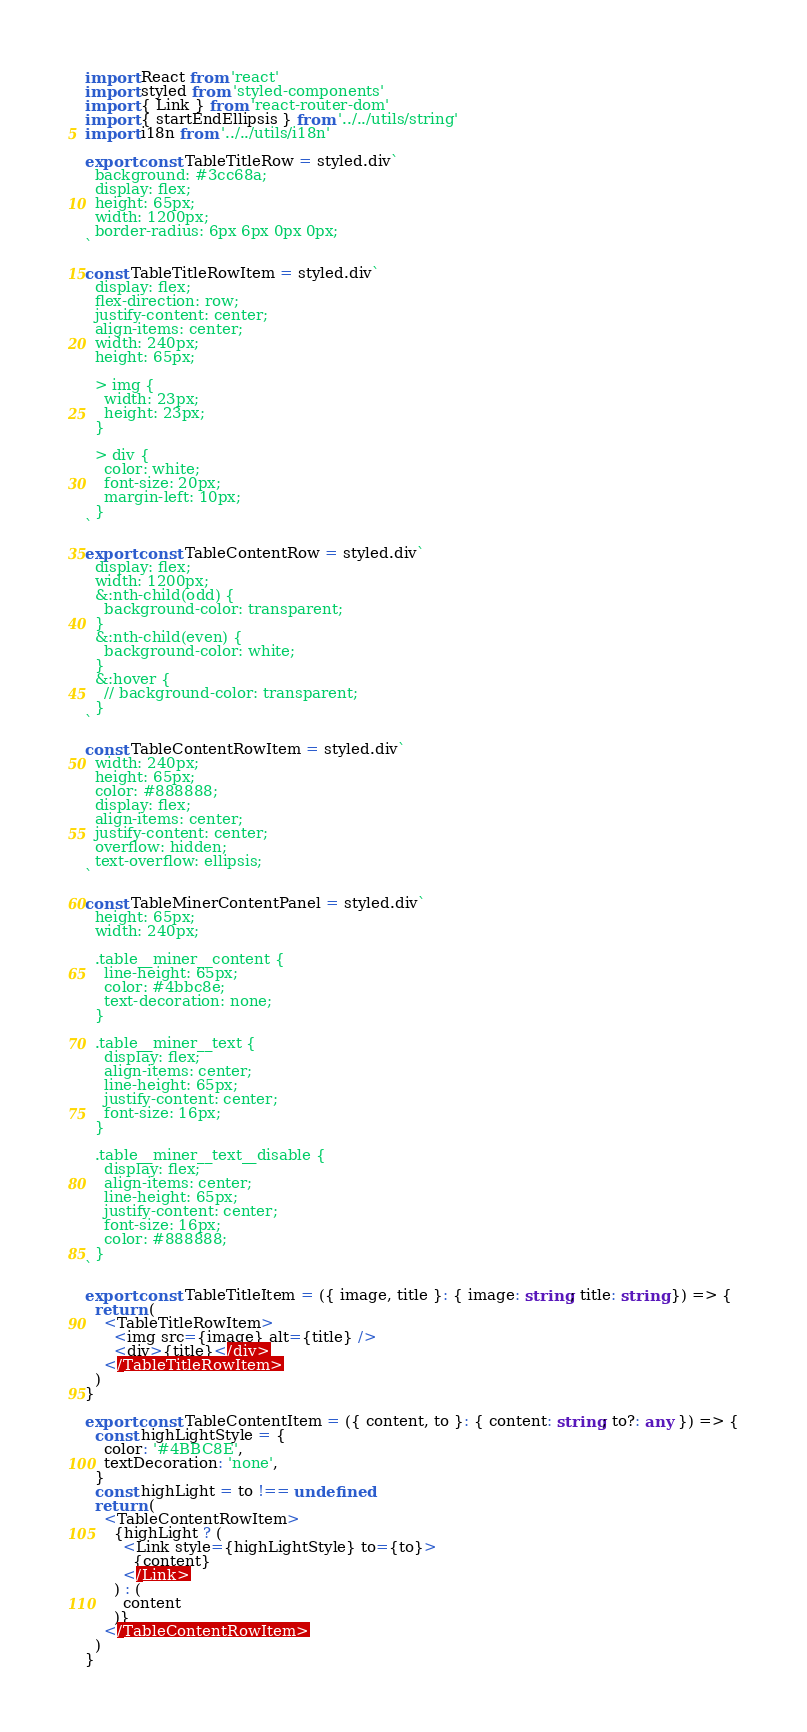<code> <loc_0><loc_0><loc_500><loc_500><_TypeScript_>import React from 'react'
import styled from 'styled-components'
import { Link } from 'react-router-dom'
import { startEndEllipsis } from '../../utils/string'
import i18n from '../../utils/i18n'

export const TableTitleRow = styled.div`
  background: #3cc68a;
  display: flex;
  height: 65px;
  width: 1200px;
  border-radius: 6px 6px 0px 0px;
`

const TableTitleRowItem = styled.div`
  display: flex;
  flex-direction: row;
  justify-content: center;
  align-items: center;
  width: 240px;
  height: 65px;

  > img {
    width: 23px;
    height: 23px;
  }

  > div {
    color: white;
    font-size: 20px;
    margin-left: 10px;
  }
`

export const TableContentRow = styled.div`
  display: flex;
  width: 1200px;
  &:nth-child(odd) {
    background-color: transparent;
  }
  &:nth-child(even) {
    background-color: white;
  }
  &:hover {
    // background-color: transparent;
  }
`

const TableContentRowItem = styled.div`
  width: 240px;
  height: 65px;
  color: #888888;
  display: flex;
  align-items: center;
  justify-content: center;
  overflow: hidden;
  text-overflow: ellipsis;
`

const TableMinerContentPanel = styled.div`
  height: 65px;
  width: 240px;

  .table__miner__content {
    line-height: 65px;
    color: #4bbc8e;
    text-decoration: none;
  }

  .table__miner__text {
    display: flex;
    align-items: center;
    line-height: 65px;
    justify-content: center;
    font-size: 16px;
  }

  .table__miner__text__disable {
    display: flex;
    align-items: center;
    line-height: 65px;
    justify-content: center;
    font-size: 16px;
    color: #888888;
  }
`

export const TableTitleItem = ({ image, title }: { image: string; title: string }) => {
  return (
    <TableTitleRowItem>
      <img src={image} alt={title} />
      <div>{title}</div>
    </TableTitleRowItem>
  )
}

export const TableContentItem = ({ content, to }: { content: string; to?: any }) => {
  const highLightStyle = {
    color: '#4BBC8E',
    textDecoration: 'none',
  }
  const highLight = to !== undefined
  return (
    <TableContentRowItem>
      {highLight ? (
        <Link style={highLightStyle} to={to}>
          {content}
        </Link>
      ) : (
        content
      )}
    </TableContentRowItem>
  )
}
</code> 